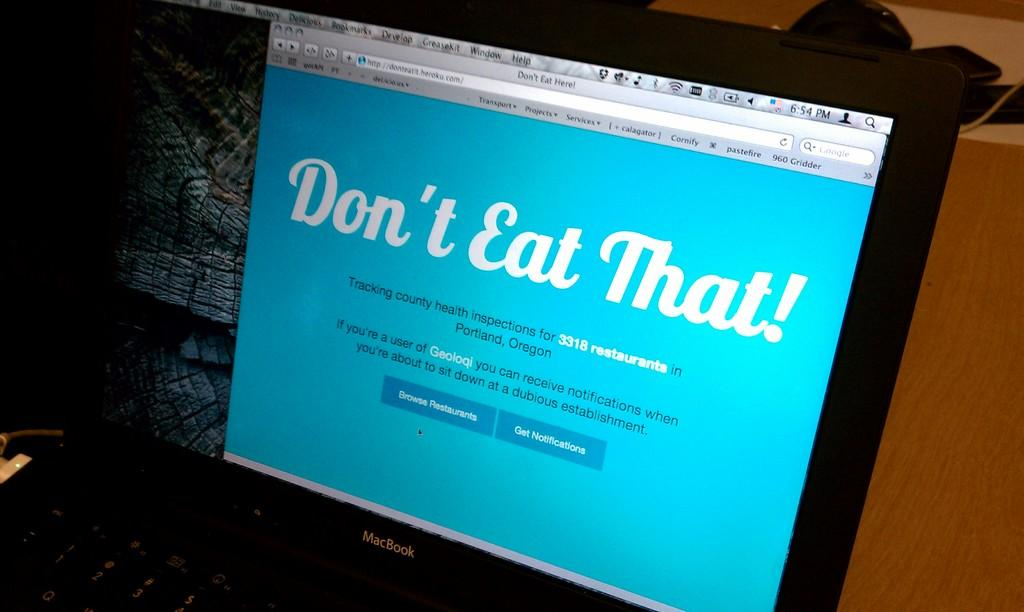<image>
Create a compact narrative representing the image presented. Macbook computer monitor that says Don't Eat That. 